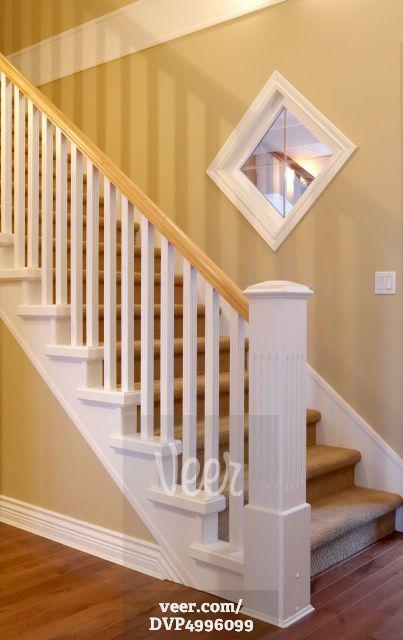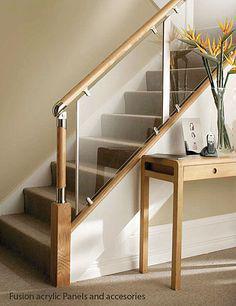The first image is the image on the left, the second image is the image on the right. Analyze the images presented: Is the assertion "The plant in the image on the left is sitting beside the stairway." valid? Answer yes or no. No. 